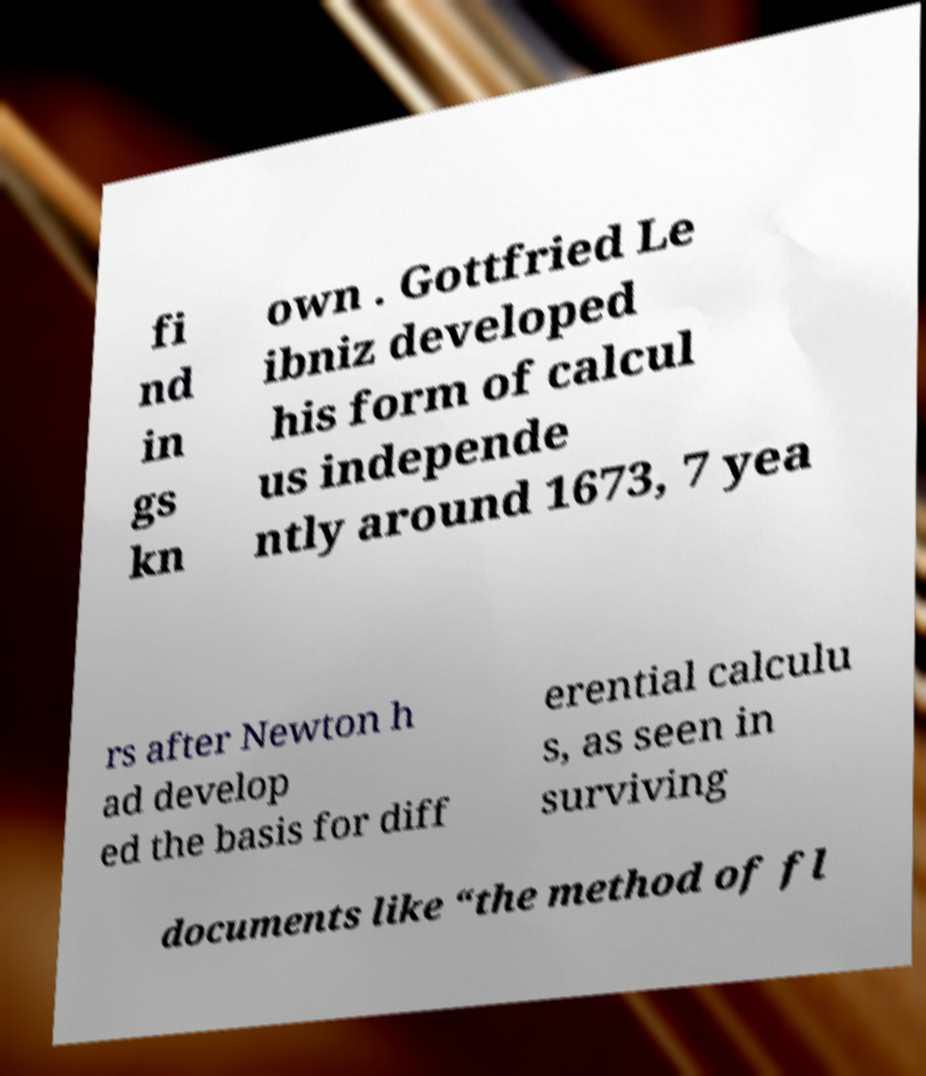I need the written content from this picture converted into text. Can you do that? fi nd in gs kn own . Gottfried Le ibniz developed his form of calcul us independe ntly around 1673, 7 yea rs after Newton h ad develop ed the basis for diff erential calculu s, as seen in surviving documents like “the method of fl 